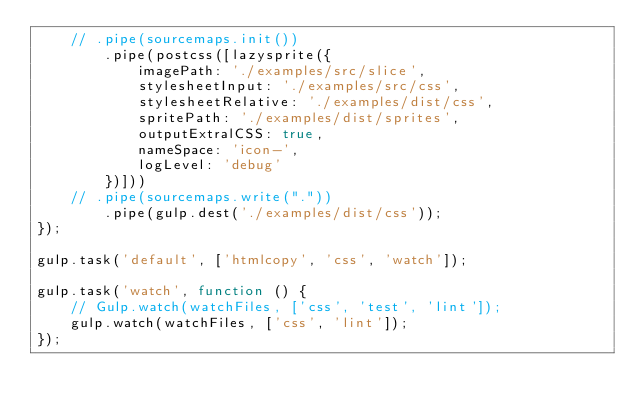<code> <loc_0><loc_0><loc_500><loc_500><_JavaScript_>	// .pipe(sourcemaps.init())
		.pipe(postcss([lazysprite({
			imagePath: './examples/src/slice',
			stylesheetInput: './examples/src/css',
			stylesheetRelative: './examples/dist/css',
			spritePath: './examples/dist/sprites',
			outputExtralCSS: true,
			nameSpace: 'icon-',
			logLevel: 'debug'
		})]))
	// .pipe(sourcemaps.write("."))
		.pipe(gulp.dest('./examples/dist/css'));
});

gulp.task('default', ['htmlcopy', 'css', 'watch']);

gulp.task('watch', function () {
	// Gulp.watch(watchFiles, ['css', 'test', 'lint']);
	gulp.watch(watchFiles, ['css', 'lint']);
});
</code> 